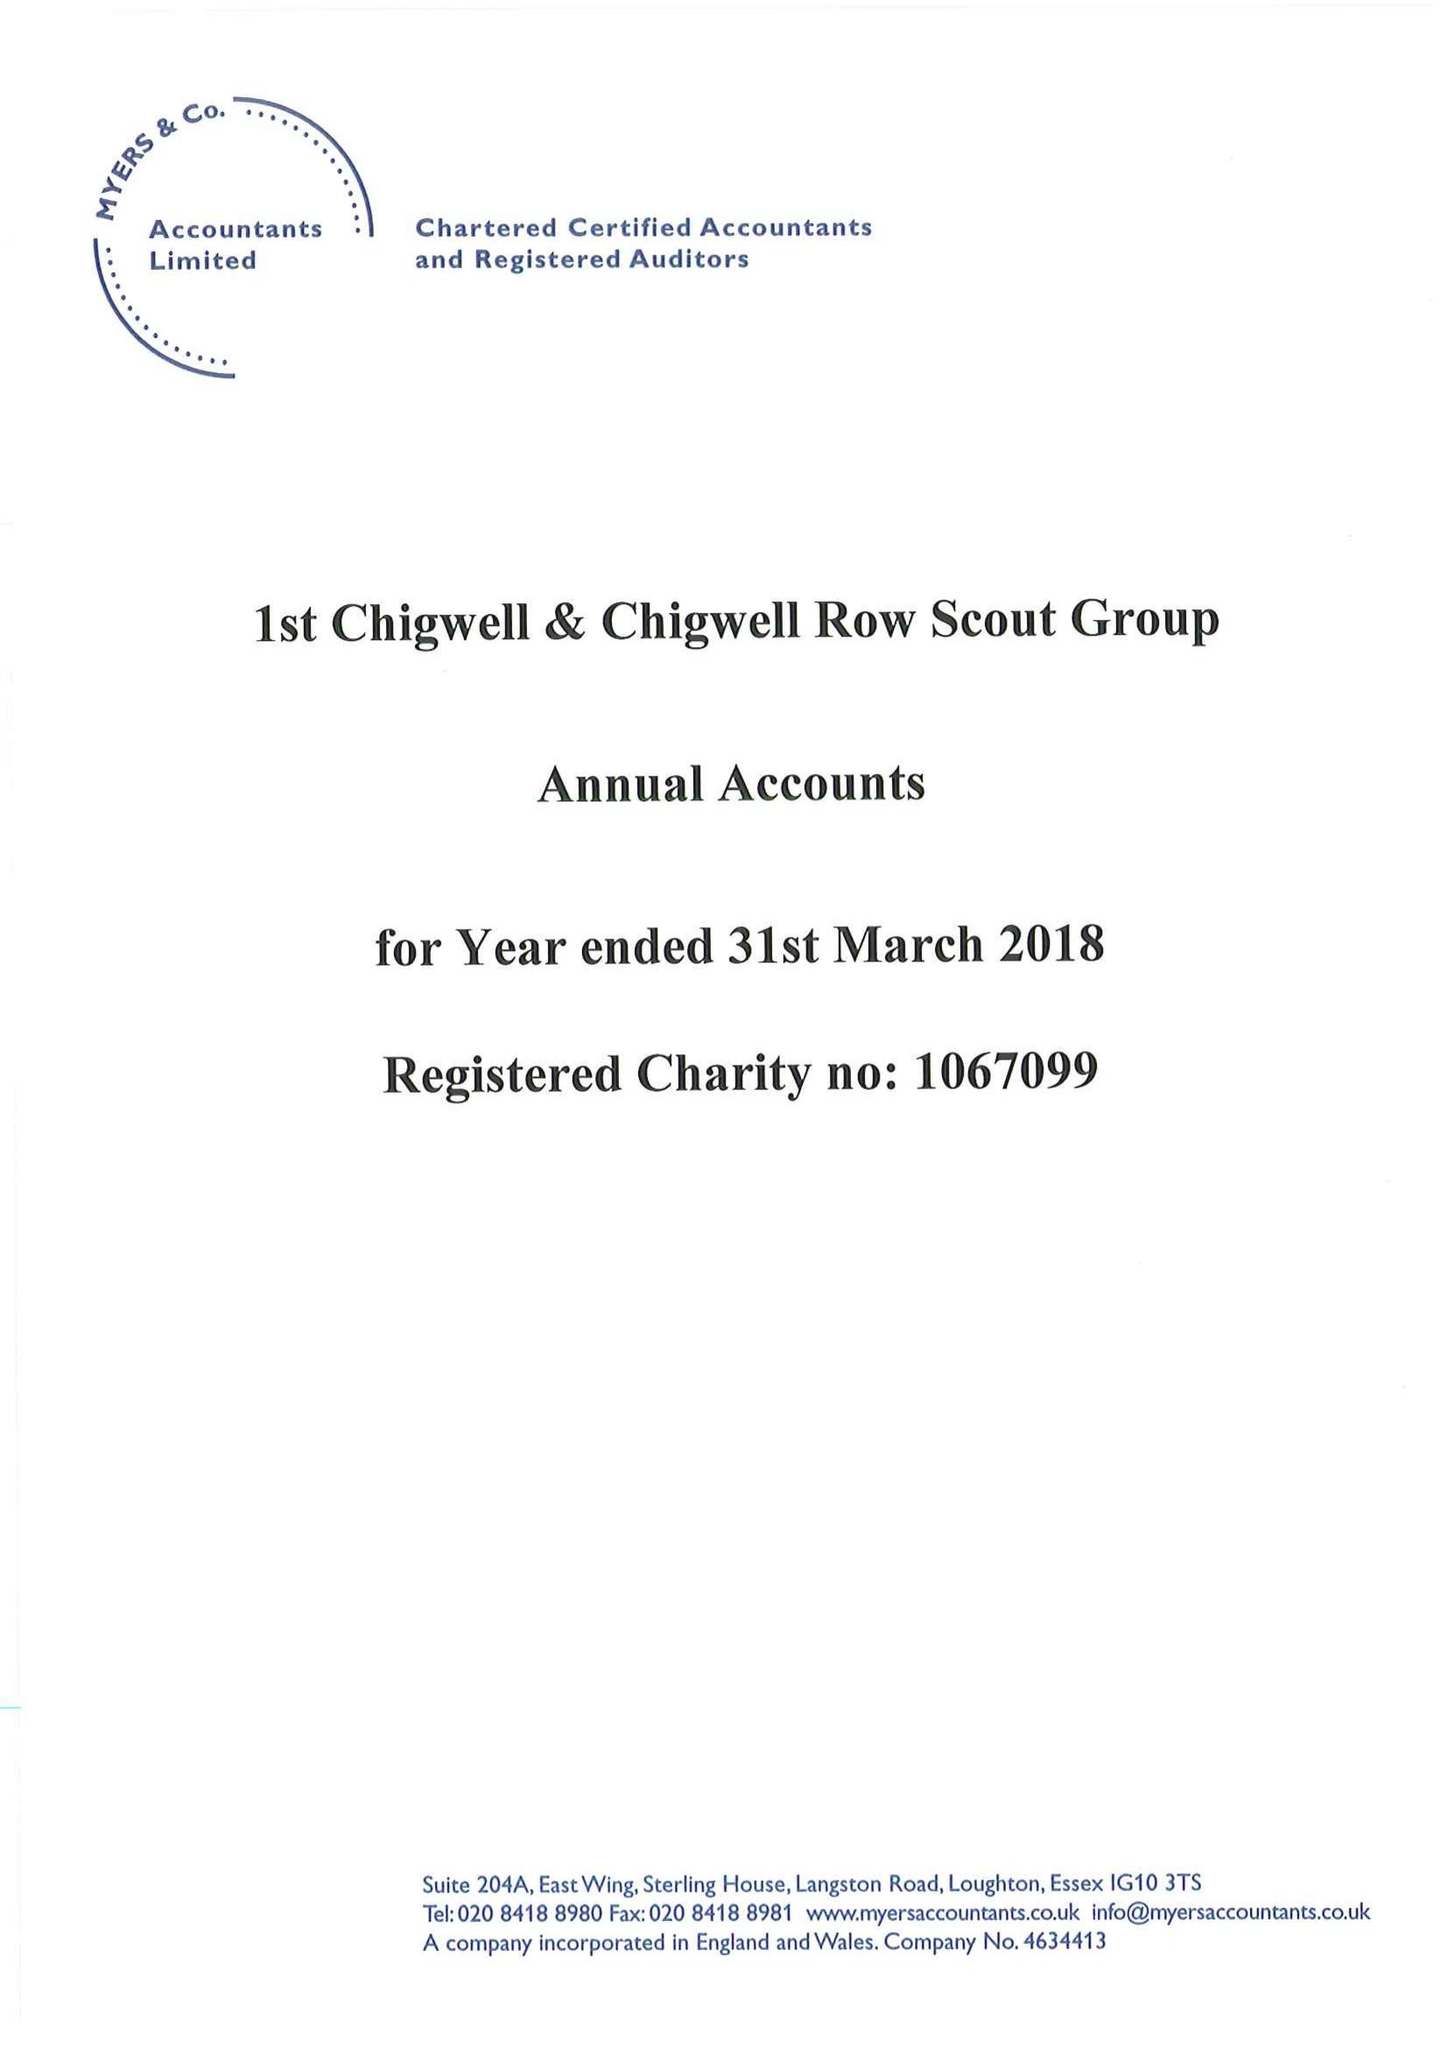What is the value for the charity_name?
Answer the question using a single word or phrase. 1st Chigwell and Chigwell Row Scout Group 